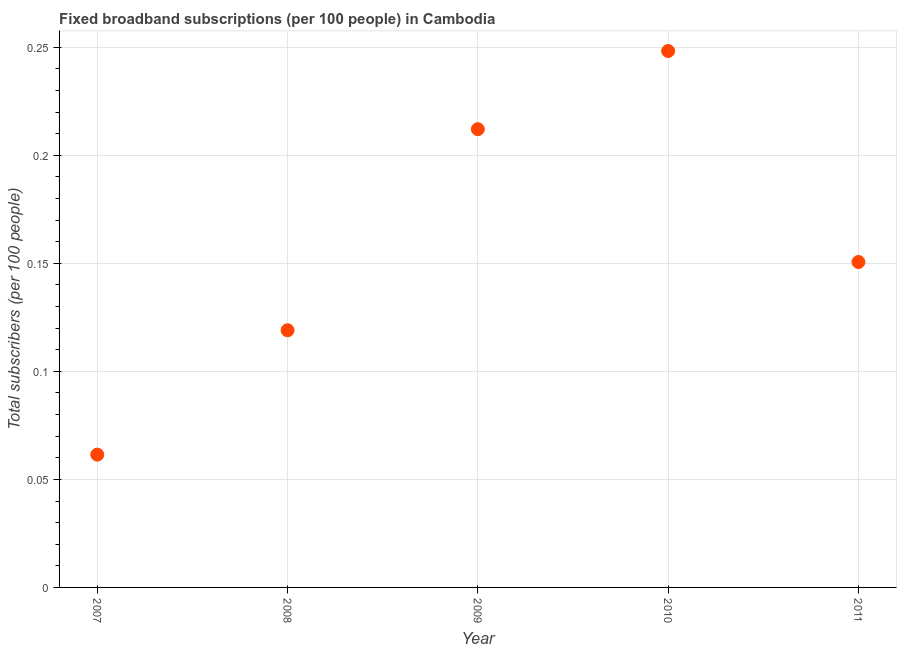What is the total number of fixed broadband subscriptions in 2008?
Offer a very short reply. 0.12. Across all years, what is the maximum total number of fixed broadband subscriptions?
Provide a succinct answer. 0.25. Across all years, what is the minimum total number of fixed broadband subscriptions?
Make the answer very short. 0.06. In which year was the total number of fixed broadband subscriptions maximum?
Offer a very short reply. 2010. In which year was the total number of fixed broadband subscriptions minimum?
Make the answer very short. 2007. What is the sum of the total number of fixed broadband subscriptions?
Provide a succinct answer. 0.79. What is the difference between the total number of fixed broadband subscriptions in 2007 and 2010?
Offer a terse response. -0.19. What is the average total number of fixed broadband subscriptions per year?
Keep it short and to the point. 0.16. What is the median total number of fixed broadband subscriptions?
Make the answer very short. 0.15. In how many years, is the total number of fixed broadband subscriptions greater than 0.22 ?
Provide a succinct answer. 1. What is the ratio of the total number of fixed broadband subscriptions in 2007 to that in 2008?
Make the answer very short. 0.52. Is the total number of fixed broadband subscriptions in 2007 less than that in 2011?
Your answer should be compact. Yes. Is the difference between the total number of fixed broadband subscriptions in 2007 and 2009 greater than the difference between any two years?
Offer a terse response. No. What is the difference between the highest and the second highest total number of fixed broadband subscriptions?
Provide a short and direct response. 0.04. Is the sum of the total number of fixed broadband subscriptions in 2008 and 2010 greater than the maximum total number of fixed broadband subscriptions across all years?
Ensure brevity in your answer.  Yes. What is the difference between the highest and the lowest total number of fixed broadband subscriptions?
Keep it short and to the point. 0.19. In how many years, is the total number of fixed broadband subscriptions greater than the average total number of fixed broadband subscriptions taken over all years?
Ensure brevity in your answer.  2. Does the total number of fixed broadband subscriptions monotonically increase over the years?
Give a very brief answer. No. How many years are there in the graph?
Your response must be concise. 5. Does the graph contain any zero values?
Offer a terse response. No. Does the graph contain grids?
Provide a succinct answer. Yes. What is the title of the graph?
Your answer should be compact. Fixed broadband subscriptions (per 100 people) in Cambodia. What is the label or title of the Y-axis?
Make the answer very short. Total subscribers (per 100 people). What is the Total subscribers (per 100 people) in 2007?
Provide a succinct answer. 0.06. What is the Total subscribers (per 100 people) in 2008?
Your response must be concise. 0.12. What is the Total subscribers (per 100 people) in 2009?
Give a very brief answer. 0.21. What is the Total subscribers (per 100 people) in 2010?
Give a very brief answer. 0.25. What is the Total subscribers (per 100 people) in 2011?
Offer a very short reply. 0.15. What is the difference between the Total subscribers (per 100 people) in 2007 and 2008?
Ensure brevity in your answer.  -0.06. What is the difference between the Total subscribers (per 100 people) in 2007 and 2009?
Offer a very short reply. -0.15. What is the difference between the Total subscribers (per 100 people) in 2007 and 2010?
Give a very brief answer. -0.19. What is the difference between the Total subscribers (per 100 people) in 2007 and 2011?
Ensure brevity in your answer.  -0.09. What is the difference between the Total subscribers (per 100 people) in 2008 and 2009?
Your answer should be very brief. -0.09. What is the difference between the Total subscribers (per 100 people) in 2008 and 2010?
Your response must be concise. -0.13. What is the difference between the Total subscribers (per 100 people) in 2008 and 2011?
Your answer should be compact. -0.03. What is the difference between the Total subscribers (per 100 people) in 2009 and 2010?
Offer a very short reply. -0.04. What is the difference between the Total subscribers (per 100 people) in 2009 and 2011?
Provide a short and direct response. 0.06. What is the difference between the Total subscribers (per 100 people) in 2010 and 2011?
Provide a short and direct response. 0.1. What is the ratio of the Total subscribers (per 100 people) in 2007 to that in 2008?
Keep it short and to the point. 0.52. What is the ratio of the Total subscribers (per 100 people) in 2007 to that in 2009?
Your response must be concise. 0.29. What is the ratio of the Total subscribers (per 100 people) in 2007 to that in 2010?
Provide a short and direct response. 0.25. What is the ratio of the Total subscribers (per 100 people) in 2007 to that in 2011?
Provide a succinct answer. 0.41. What is the ratio of the Total subscribers (per 100 people) in 2008 to that in 2009?
Provide a succinct answer. 0.56. What is the ratio of the Total subscribers (per 100 people) in 2008 to that in 2010?
Provide a succinct answer. 0.48. What is the ratio of the Total subscribers (per 100 people) in 2008 to that in 2011?
Your response must be concise. 0.79. What is the ratio of the Total subscribers (per 100 people) in 2009 to that in 2010?
Keep it short and to the point. 0.85. What is the ratio of the Total subscribers (per 100 people) in 2009 to that in 2011?
Your answer should be very brief. 1.41. What is the ratio of the Total subscribers (per 100 people) in 2010 to that in 2011?
Keep it short and to the point. 1.65. 